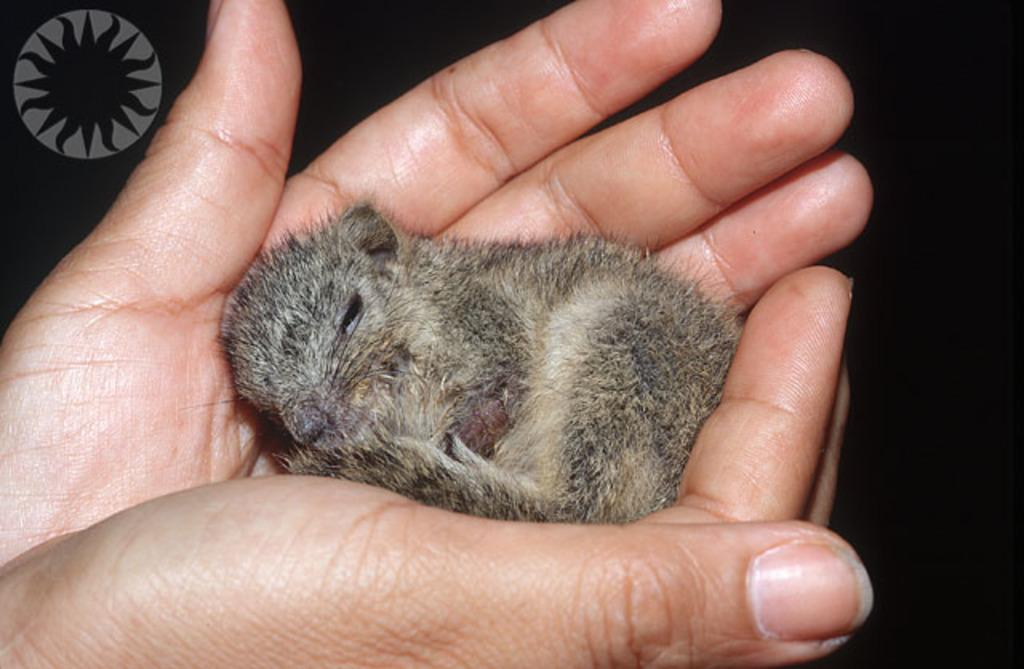What body parts of a person are visible in the image? There are a person's hands visible in the image. What is on the person's hands? There is an animal on the person's hands. What can be seen in the top left corner of the image? There is a logo in the top left corner of the image. How would you describe the overall color scheme of the image? The background of the image is dark. What type of amusement can be seen in the image? There is no amusement present in the image; it features a person's hands holding an animal. How many competitors are participating in the competition in the image? There is no competition present in the image; it features a person's hands holding an animal. 